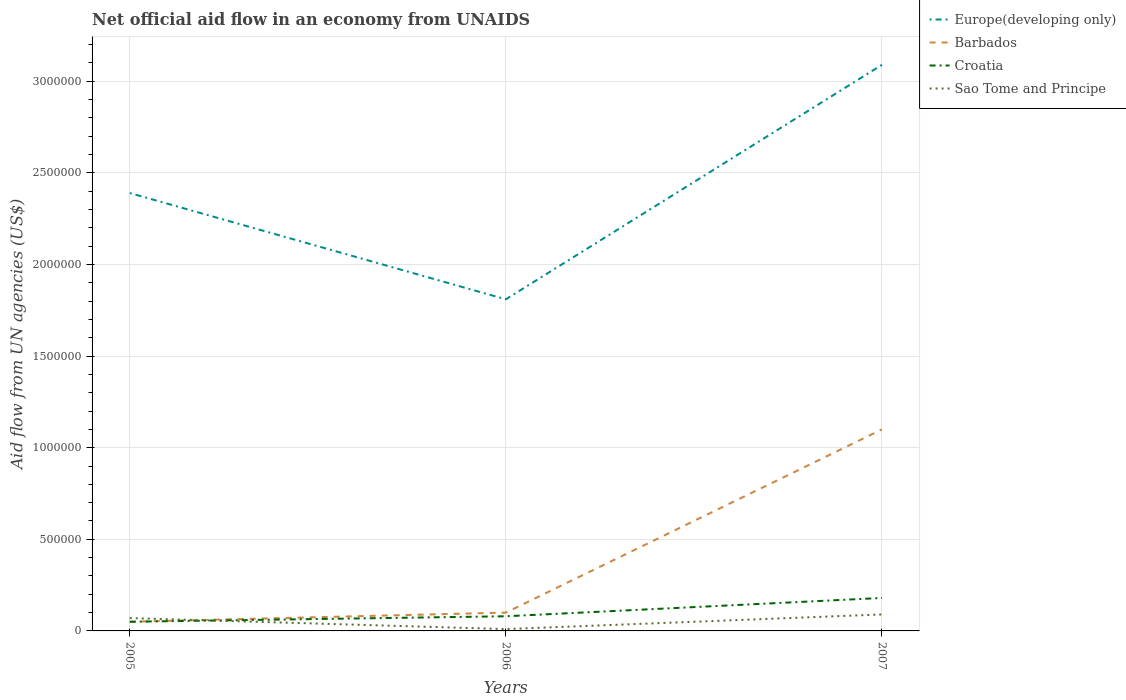Does the line corresponding to Sao Tome and Principe intersect with the line corresponding to Europe(developing only)?
Provide a short and direct response. No. Is the number of lines equal to the number of legend labels?
Ensure brevity in your answer.  Yes. Across all years, what is the maximum net official aid flow in Europe(developing only)?
Provide a short and direct response. 1.81e+06. What is the total net official aid flow in Croatia in the graph?
Ensure brevity in your answer.  -1.30e+05. Is the net official aid flow in Sao Tome and Principe strictly greater than the net official aid flow in Europe(developing only) over the years?
Keep it short and to the point. Yes. How many lines are there?
Provide a succinct answer. 4. Are the values on the major ticks of Y-axis written in scientific E-notation?
Provide a short and direct response. No. How many legend labels are there?
Your answer should be very brief. 4. How are the legend labels stacked?
Keep it short and to the point. Vertical. What is the title of the graph?
Provide a short and direct response. Net official aid flow in an economy from UNAIDS. Does "Russian Federation" appear as one of the legend labels in the graph?
Your answer should be compact. No. What is the label or title of the X-axis?
Keep it short and to the point. Years. What is the label or title of the Y-axis?
Your response must be concise. Aid flow from UN agencies (US$). What is the Aid flow from UN agencies (US$) of Europe(developing only) in 2005?
Give a very brief answer. 2.39e+06. What is the Aid flow from UN agencies (US$) of Croatia in 2005?
Provide a succinct answer. 5.00e+04. What is the Aid flow from UN agencies (US$) of Sao Tome and Principe in 2005?
Offer a terse response. 7.00e+04. What is the Aid flow from UN agencies (US$) of Europe(developing only) in 2006?
Your answer should be compact. 1.81e+06. What is the Aid flow from UN agencies (US$) in Croatia in 2006?
Give a very brief answer. 8.00e+04. What is the Aid flow from UN agencies (US$) of Sao Tome and Principe in 2006?
Ensure brevity in your answer.  10000. What is the Aid flow from UN agencies (US$) of Europe(developing only) in 2007?
Provide a short and direct response. 3.09e+06. What is the Aid flow from UN agencies (US$) in Barbados in 2007?
Ensure brevity in your answer.  1.10e+06. What is the Aid flow from UN agencies (US$) of Croatia in 2007?
Your answer should be very brief. 1.80e+05. What is the Aid flow from UN agencies (US$) in Sao Tome and Principe in 2007?
Your response must be concise. 9.00e+04. Across all years, what is the maximum Aid flow from UN agencies (US$) of Europe(developing only)?
Offer a terse response. 3.09e+06. Across all years, what is the maximum Aid flow from UN agencies (US$) in Barbados?
Provide a short and direct response. 1.10e+06. Across all years, what is the maximum Aid flow from UN agencies (US$) of Sao Tome and Principe?
Give a very brief answer. 9.00e+04. Across all years, what is the minimum Aid flow from UN agencies (US$) in Europe(developing only)?
Keep it short and to the point. 1.81e+06. Across all years, what is the minimum Aid flow from UN agencies (US$) of Croatia?
Offer a terse response. 5.00e+04. Across all years, what is the minimum Aid flow from UN agencies (US$) in Sao Tome and Principe?
Ensure brevity in your answer.  10000. What is the total Aid flow from UN agencies (US$) in Europe(developing only) in the graph?
Provide a succinct answer. 7.29e+06. What is the total Aid flow from UN agencies (US$) in Barbados in the graph?
Your response must be concise. 1.25e+06. What is the total Aid flow from UN agencies (US$) in Croatia in the graph?
Your response must be concise. 3.10e+05. What is the total Aid flow from UN agencies (US$) of Sao Tome and Principe in the graph?
Give a very brief answer. 1.70e+05. What is the difference between the Aid flow from UN agencies (US$) in Europe(developing only) in 2005 and that in 2006?
Provide a short and direct response. 5.80e+05. What is the difference between the Aid flow from UN agencies (US$) of Barbados in 2005 and that in 2006?
Provide a succinct answer. -5.00e+04. What is the difference between the Aid flow from UN agencies (US$) in Europe(developing only) in 2005 and that in 2007?
Provide a succinct answer. -7.00e+05. What is the difference between the Aid flow from UN agencies (US$) in Barbados in 2005 and that in 2007?
Your answer should be very brief. -1.05e+06. What is the difference between the Aid flow from UN agencies (US$) in Croatia in 2005 and that in 2007?
Provide a short and direct response. -1.30e+05. What is the difference between the Aid flow from UN agencies (US$) in Sao Tome and Principe in 2005 and that in 2007?
Your response must be concise. -2.00e+04. What is the difference between the Aid flow from UN agencies (US$) in Europe(developing only) in 2006 and that in 2007?
Give a very brief answer. -1.28e+06. What is the difference between the Aid flow from UN agencies (US$) in Barbados in 2006 and that in 2007?
Your answer should be very brief. -1.00e+06. What is the difference between the Aid flow from UN agencies (US$) of Europe(developing only) in 2005 and the Aid flow from UN agencies (US$) of Barbados in 2006?
Provide a short and direct response. 2.29e+06. What is the difference between the Aid flow from UN agencies (US$) of Europe(developing only) in 2005 and the Aid flow from UN agencies (US$) of Croatia in 2006?
Your response must be concise. 2.31e+06. What is the difference between the Aid flow from UN agencies (US$) of Europe(developing only) in 2005 and the Aid flow from UN agencies (US$) of Sao Tome and Principe in 2006?
Give a very brief answer. 2.38e+06. What is the difference between the Aid flow from UN agencies (US$) of Barbados in 2005 and the Aid flow from UN agencies (US$) of Croatia in 2006?
Give a very brief answer. -3.00e+04. What is the difference between the Aid flow from UN agencies (US$) of Croatia in 2005 and the Aid flow from UN agencies (US$) of Sao Tome and Principe in 2006?
Give a very brief answer. 4.00e+04. What is the difference between the Aid flow from UN agencies (US$) in Europe(developing only) in 2005 and the Aid flow from UN agencies (US$) in Barbados in 2007?
Give a very brief answer. 1.29e+06. What is the difference between the Aid flow from UN agencies (US$) of Europe(developing only) in 2005 and the Aid flow from UN agencies (US$) of Croatia in 2007?
Your answer should be very brief. 2.21e+06. What is the difference between the Aid flow from UN agencies (US$) of Europe(developing only) in 2005 and the Aid flow from UN agencies (US$) of Sao Tome and Principe in 2007?
Provide a short and direct response. 2.30e+06. What is the difference between the Aid flow from UN agencies (US$) in Croatia in 2005 and the Aid flow from UN agencies (US$) in Sao Tome and Principe in 2007?
Make the answer very short. -4.00e+04. What is the difference between the Aid flow from UN agencies (US$) of Europe(developing only) in 2006 and the Aid flow from UN agencies (US$) of Barbados in 2007?
Offer a terse response. 7.10e+05. What is the difference between the Aid flow from UN agencies (US$) in Europe(developing only) in 2006 and the Aid flow from UN agencies (US$) in Croatia in 2007?
Your answer should be compact. 1.63e+06. What is the difference between the Aid flow from UN agencies (US$) of Europe(developing only) in 2006 and the Aid flow from UN agencies (US$) of Sao Tome and Principe in 2007?
Provide a short and direct response. 1.72e+06. What is the average Aid flow from UN agencies (US$) of Europe(developing only) per year?
Provide a succinct answer. 2.43e+06. What is the average Aid flow from UN agencies (US$) of Barbados per year?
Offer a very short reply. 4.17e+05. What is the average Aid flow from UN agencies (US$) in Croatia per year?
Your response must be concise. 1.03e+05. What is the average Aid flow from UN agencies (US$) in Sao Tome and Principe per year?
Offer a very short reply. 5.67e+04. In the year 2005, what is the difference between the Aid flow from UN agencies (US$) of Europe(developing only) and Aid flow from UN agencies (US$) of Barbados?
Give a very brief answer. 2.34e+06. In the year 2005, what is the difference between the Aid flow from UN agencies (US$) in Europe(developing only) and Aid flow from UN agencies (US$) in Croatia?
Make the answer very short. 2.34e+06. In the year 2005, what is the difference between the Aid flow from UN agencies (US$) in Europe(developing only) and Aid flow from UN agencies (US$) in Sao Tome and Principe?
Your answer should be compact. 2.32e+06. In the year 2005, what is the difference between the Aid flow from UN agencies (US$) of Barbados and Aid flow from UN agencies (US$) of Sao Tome and Principe?
Your response must be concise. -2.00e+04. In the year 2005, what is the difference between the Aid flow from UN agencies (US$) in Croatia and Aid flow from UN agencies (US$) in Sao Tome and Principe?
Offer a very short reply. -2.00e+04. In the year 2006, what is the difference between the Aid flow from UN agencies (US$) in Europe(developing only) and Aid flow from UN agencies (US$) in Barbados?
Provide a succinct answer. 1.71e+06. In the year 2006, what is the difference between the Aid flow from UN agencies (US$) of Europe(developing only) and Aid flow from UN agencies (US$) of Croatia?
Provide a short and direct response. 1.73e+06. In the year 2006, what is the difference between the Aid flow from UN agencies (US$) of Europe(developing only) and Aid flow from UN agencies (US$) of Sao Tome and Principe?
Offer a terse response. 1.80e+06. In the year 2006, what is the difference between the Aid flow from UN agencies (US$) in Barbados and Aid flow from UN agencies (US$) in Croatia?
Provide a succinct answer. 2.00e+04. In the year 2006, what is the difference between the Aid flow from UN agencies (US$) in Barbados and Aid flow from UN agencies (US$) in Sao Tome and Principe?
Make the answer very short. 9.00e+04. In the year 2007, what is the difference between the Aid flow from UN agencies (US$) of Europe(developing only) and Aid flow from UN agencies (US$) of Barbados?
Your response must be concise. 1.99e+06. In the year 2007, what is the difference between the Aid flow from UN agencies (US$) of Europe(developing only) and Aid flow from UN agencies (US$) of Croatia?
Ensure brevity in your answer.  2.91e+06. In the year 2007, what is the difference between the Aid flow from UN agencies (US$) in Barbados and Aid flow from UN agencies (US$) in Croatia?
Your answer should be very brief. 9.20e+05. In the year 2007, what is the difference between the Aid flow from UN agencies (US$) in Barbados and Aid flow from UN agencies (US$) in Sao Tome and Principe?
Make the answer very short. 1.01e+06. What is the ratio of the Aid flow from UN agencies (US$) in Europe(developing only) in 2005 to that in 2006?
Keep it short and to the point. 1.32. What is the ratio of the Aid flow from UN agencies (US$) in Barbados in 2005 to that in 2006?
Offer a terse response. 0.5. What is the ratio of the Aid flow from UN agencies (US$) of Sao Tome and Principe in 2005 to that in 2006?
Provide a succinct answer. 7. What is the ratio of the Aid flow from UN agencies (US$) of Europe(developing only) in 2005 to that in 2007?
Your answer should be compact. 0.77. What is the ratio of the Aid flow from UN agencies (US$) of Barbados in 2005 to that in 2007?
Your response must be concise. 0.05. What is the ratio of the Aid flow from UN agencies (US$) of Croatia in 2005 to that in 2007?
Your answer should be very brief. 0.28. What is the ratio of the Aid flow from UN agencies (US$) in Europe(developing only) in 2006 to that in 2007?
Ensure brevity in your answer.  0.59. What is the ratio of the Aid flow from UN agencies (US$) in Barbados in 2006 to that in 2007?
Keep it short and to the point. 0.09. What is the ratio of the Aid flow from UN agencies (US$) of Croatia in 2006 to that in 2007?
Give a very brief answer. 0.44. What is the difference between the highest and the second highest Aid flow from UN agencies (US$) in Europe(developing only)?
Your answer should be compact. 7.00e+05. What is the difference between the highest and the second highest Aid flow from UN agencies (US$) in Barbados?
Make the answer very short. 1.00e+06. What is the difference between the highest and the second highest Aid flow from UN agencies (US$) in Croatia?
Keep it short and to the point. 1.00e+05. What is the difference between the highest and the second highest Aid flow from UN agencies (US$) in Sao Tome and Principe?
Offer a terse response. 2.00e+04. What is the difference between the highest and the lowest Aid flow from UN agencies (US$) in Europe(developing only)?
Your answer should be compact. 1.28e+06. What is the difference between the highest and the lowest Aid flow from UN agencies (US$) in Barbados?
Ensure brevity in your answer.  1.05e+06. What is the difference between the highest and the lowest Aid flow from UN agencies (US$) of Croatia?
Offer a very short reply. 1.30e+05. What is the difference between the highest and the lowest Aid flow from UN agencies (US$) in Sao Tome and Principe?
Make the answer very short. 8.00e+04. 